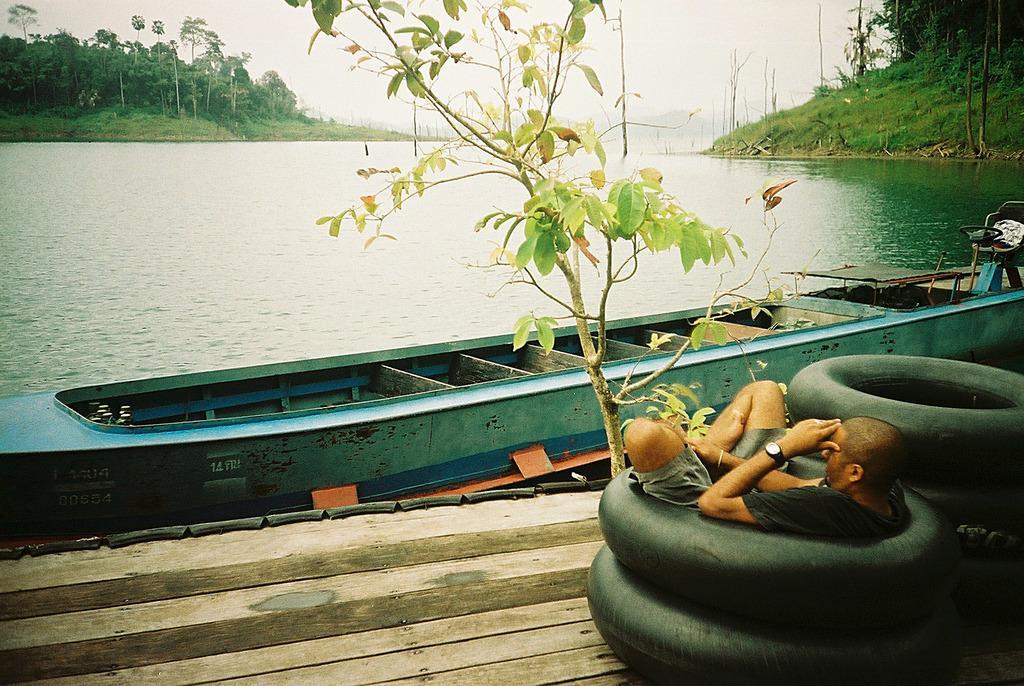In one or two sentences, can you explain what this image depicts? In this image I can see a tree, few black tubes and a man. I can also see a boat on the water. On the both sides of the image I can see number of trees, grass and in the background I can see the sky. 